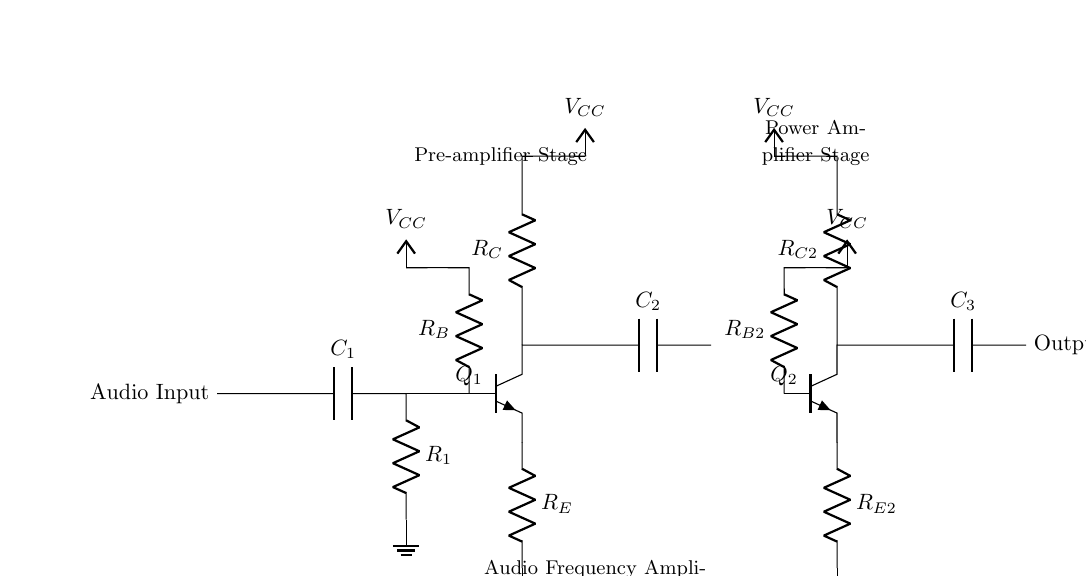What is the input component of the circuit? The input component is a capacitor labeled as C1, which allows audio signals to pass while blocking DC voltage.
Answer: C1 What type of transistors are used in this amplifier? The circuit uses two NPN transistors labeled Q1 and Q2, which amplify the audio signal by controlling the flow of current.
Answer: NPN What does the coupling capacitor C2 do in this circuit? Capacitor C2 couples the amplified signal from Q1 to Q2 while blocking DC components, ensuring only the AC portion of the signal is passed to the next stage.
Answer: Coupling What is the purpose of the resistor R_E? Resistor R_E is an emitter resistor that helps stabilize the operating point of transistor Q1 by providing negative feedback, allowing for better linearity in amplification.
Answer: Stabilization What is the overall function of this circuit? This circuit functions as an audio frequency amplifier specifically designed to amplify audio signals so they can be broadcasted over community radio.
Answer: Amplifier How are the two transistor stages arranged in relation to each other? The two transistor stages are in cascade configuration, where the output of the first stage (Q1) feeds the input of the second stage (Q2) to increase overall gain.
Answer: Cascade What would happen if R_B values were increased? Increasing the values of resistors R_B would reduce the base current for Q1 and Q2, potentially leading to decreased amplification and biasing issues due to lower transistor operation.
Answer: Decreased gain 